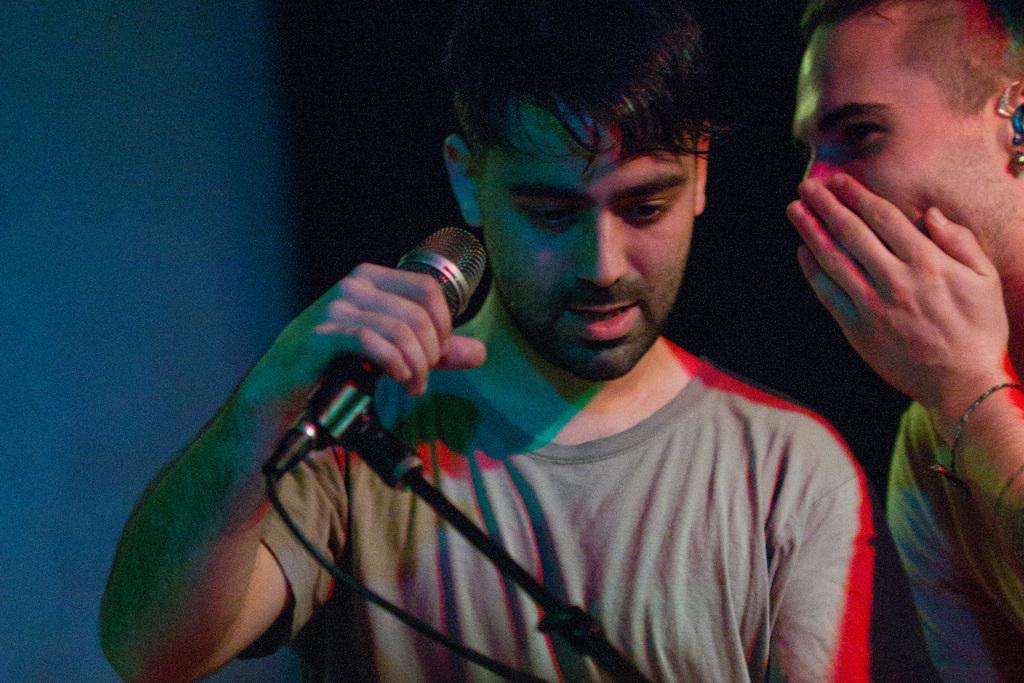What is the main subject of the image? There is a person in the image. What is the person holding in the image? The person is holding a mic with his hand. What is the person doing with his other hand in the image? The person is covering his face with his hand. What type of shock is the person experiencing in the image? There is no indication in the image that the person is experiencing any type of shock. 